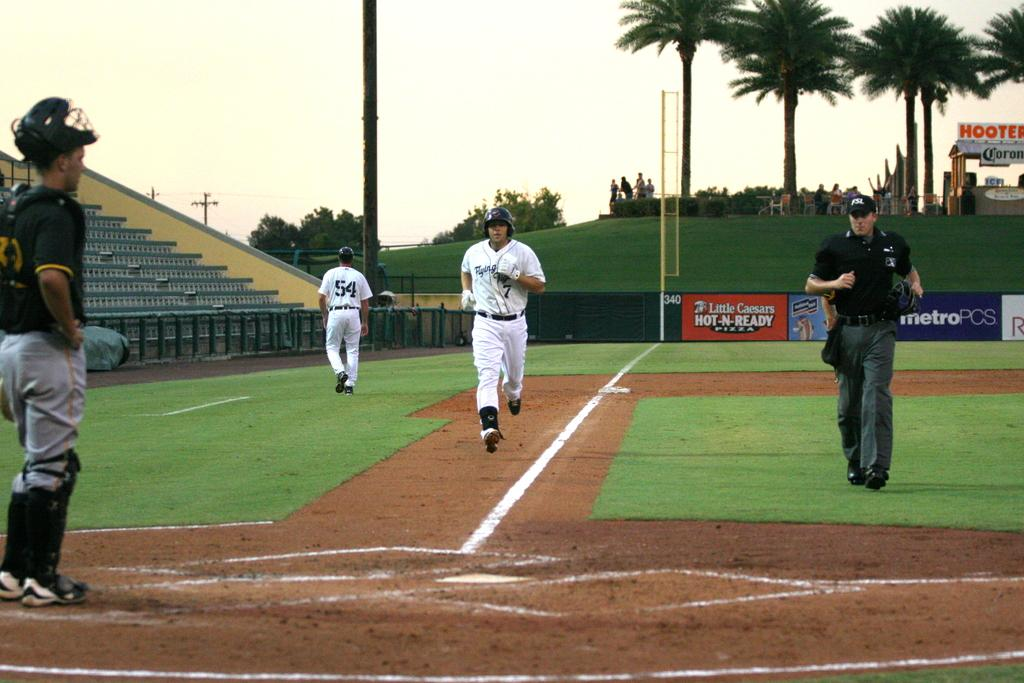<image>
Present a compact description of the photo's key features. Player number 7 runs towards home plate after hitting a home run. 